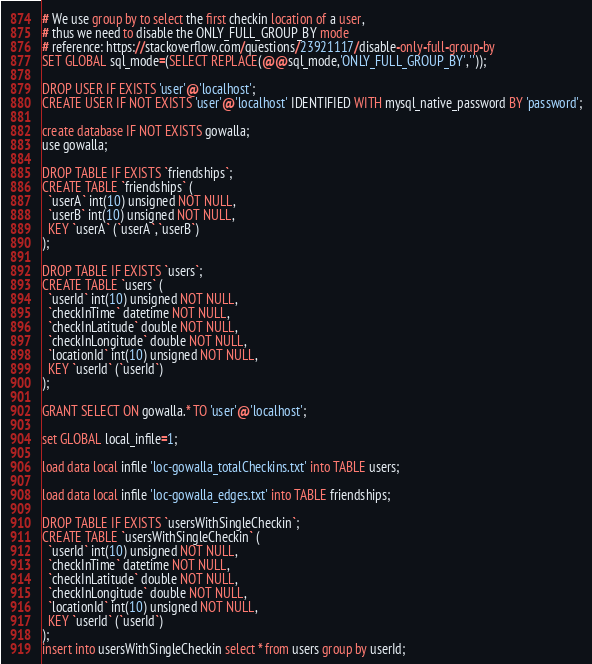<code> <loc_0><loc_0><loc_500><loc_500><_SQL_># We use group by to select the first checkin location of a user,
# thus we need to disable the ONLY_FULL_GROUP_BY mode
# reference: https://stackoverflow.com/questions/23921117/disable-only-full-group-by
SET GLOBAL sql_mode=(SELECT REPLACE(@@sql_mode,'ONLY_FULL_GROUP_BY',''));

DROP USER IF EXISTS 'user'@'localhost';
CREATE USER IF NOT EXISTS 'user'@'localhost' IDENTIFIED WITH mysql_native_password BY 'password';

create database IF NOT EXISTS gowalla;
use gowalla;

DROP TABLE IF EXISTS `friendships`;
CREATE TABLE `friendships` (
  `userA` int(10) unsigned NOT NULL,
  `userB` int(10) unsigned NOT NULL,
  KEY `userA` (`userA`,`userB`)
);

DROP TABLE IF EXISTS `users`;
CREATE TABLE `users` (
  `userId` int(10) unsigned NOT NULL,
  `checkInTime` datetime NOT NULL,
  `checkInLatitude` double NOT NULL,
  `checkInLongitude` double NOT NULL,
  `locationId` int(10) unsigned NOT NULL,
  KEY `userId` (`userId`)
);

GRANT SELECT ON gowalla.* TO 'user'@'localhost';

set GLOBAL local_infile=1;

load data local infile 'loc-gowalla_totalCheckins.txt' into TABLE users;

load data local infile 'loc-gowalla_edges.txt' into TABLE friendships;

DROP TABLE IF EXISTS `usersWithSingleCheckin`;
CREATE TABLE `usersWithSingleCheckin` (
  `userId` int(10) unsigned NOT NULL,
  `checkInTime` datetime NOT NULL,
  `checkInLatitude` double NOT NULL,
  `checkInLongitude` double NOT NULL,
  `locationId` int(10) unsigned NOT NULL,
  KEY `userId` (`userId`)
);
insert into usersWithSingleCheckin select * from users group by userId;
</code> 